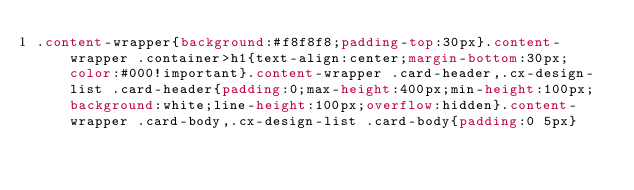Convert code to text. <code><loc_0><loc_0><loc_500><loc_500><_CSS_>.content-wrapper{background:#f8f8f8;padding-top:30px}.content-wrapper .container>h1{text-align:center;margin-bottom:30px;color:#000!important}.content-wrapper .card-header,.cx-design-list .card-header{padding:0;max-height:400px;min-height:100px;background:white;line-height:100px;overflow:hidden}.content-wrapper .card-body,.cx-design-list .card-body{padding:0 5px}</code> 